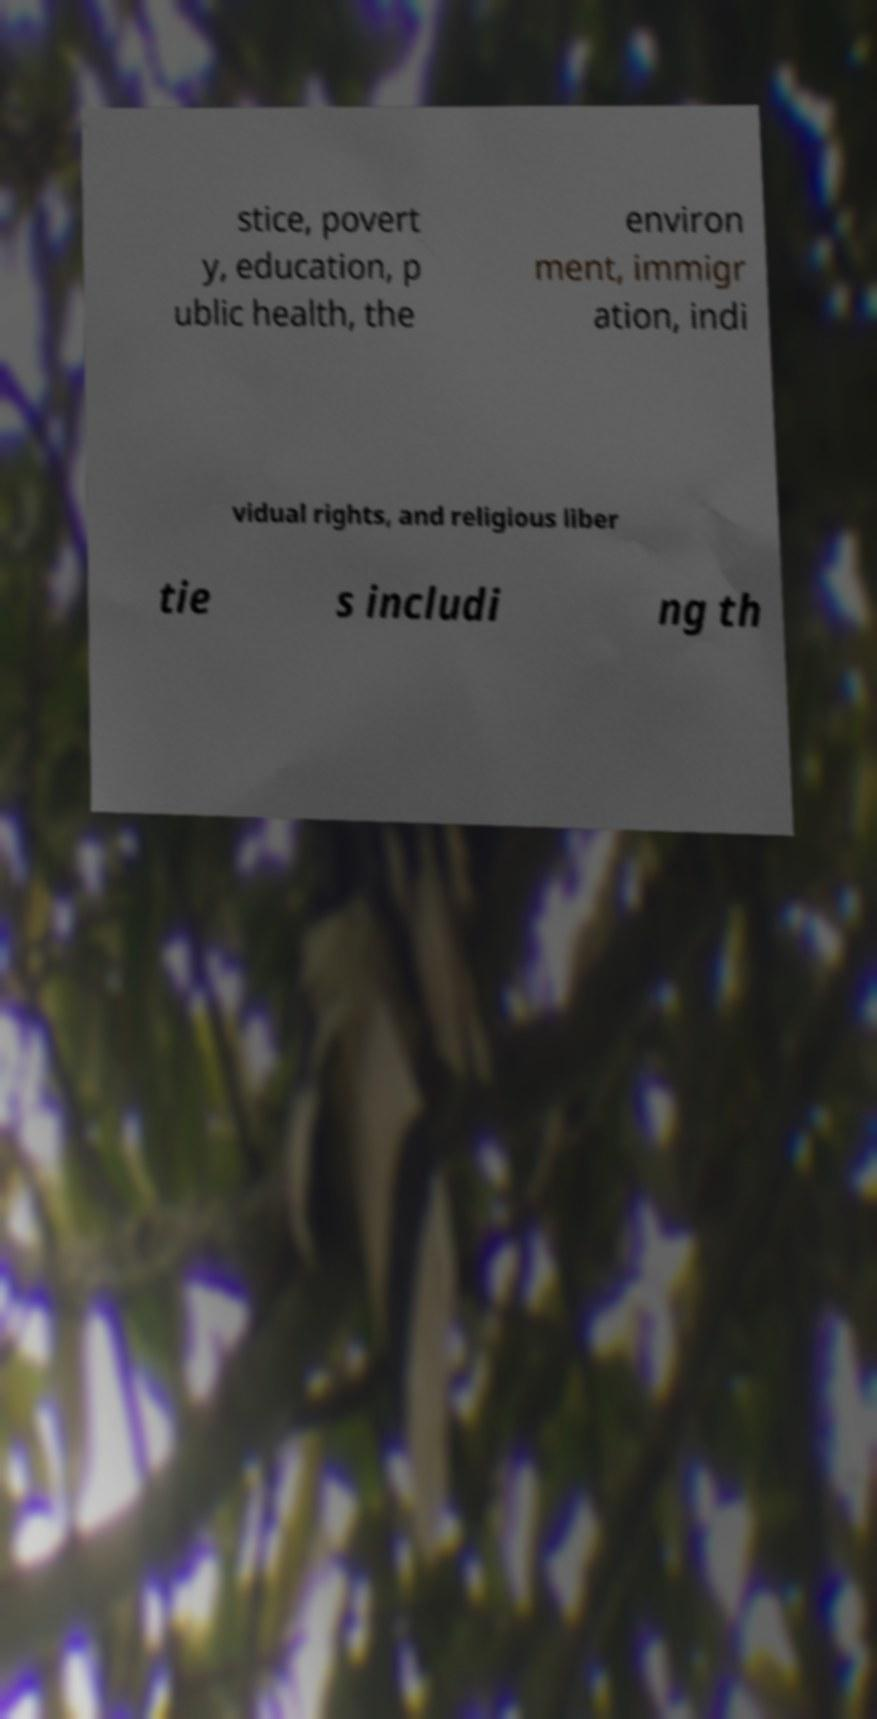Can you read and provide the text displayed in the image?This photo seems to have some interesting text. Can you extract and type it out for me? stice, povert y, education, p ublic health, the environ ment, immigr ation, indi vidual rights, and religious liber tie s includi ng th 